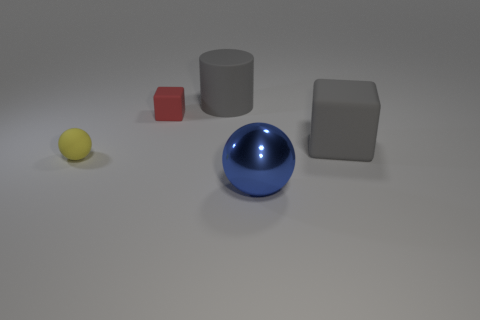Is the color of the big matte block the same as the large cylinder?
Ensure brevity in your answer.  Yes. There is a matte thing that is the same color as the big cube; what size is it?
Provide a short and direct response. Large. Is the shape of the small yellow matte object the same as the large blue object?
Provide a short and direct response. Yes. What color is the rubber object that is right of the matte cylinder?
Your answer should be very brief. Gray. Does the blue metal ball have the same size as the gray cube?
Keep it short and to the point. Yes. There is a sphere left of the thing behind the tiny red thing; what is its material?
Ensure brevity in your answer.  Rubber. How many big blocks have the same color as the cylinder?
Your response must be concise. 1. Is there anything else that has the same material as the big ball?
Your response must be concise. No. Are there fewer large gray cubes that are on the left side of the matte cylinder than large spheres?
Offer a very short reply. Yes. There is a sphere left of the shiny ball that is in front of the yellow object; what color is it?
Your response must be concise. Yellow. 